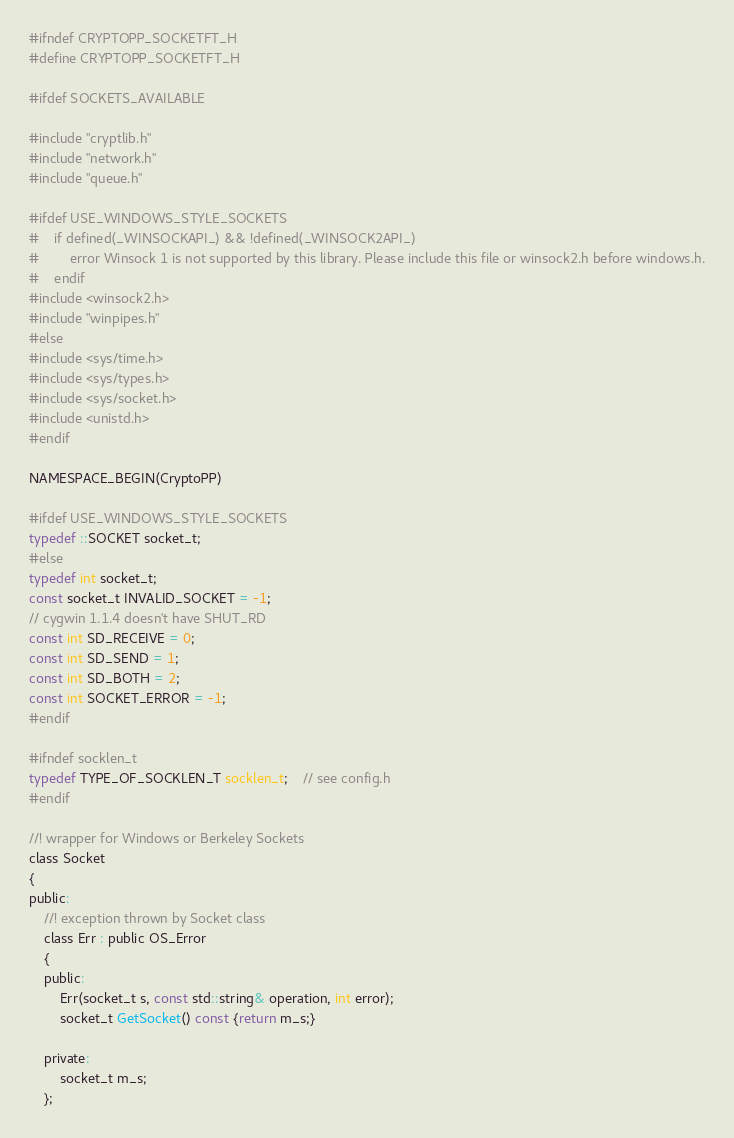Convert code to text. <code><loc_0><loc_0><loc_500><loc_500><_C_>#ifndef CRYPTOPP_SOCKETFT_H
#define CRYPTOPP_SOCKETFT_H

#ifdef SOCKETS_AVAILABLE

#include "cryptlib.h"
#include "network.h"
#include "queue.h"

#ifdef USE_WINDOWS_STYLE_SOCKETS
#	if defined(_WINSOCKAPI_) && !defined(_WINSOCK2API_)
#		error Winsock 1 is not supported by this library. Please include this file or winsock2.h before windows.h.
#	endif
#include <winsock2.h>
#include "winpipes.h"
#else
#include <sys/time.h>
#include <sys/types.h>
#include <sys/socket.h>
#include <unistd.h>
#endif

NAMESPACE_BEGIN(CryptoPP)

#ifdef USE_WINDOWS_STYLE_SOCKETS
typedef ::SOCKET socket_t;
#else
typedef int socket_t;
const socket_t INVALID_SOCKET = -1;
// cygwin 1.1.4 doesn't have SHUT_RD
const int SD_RECEIVE = 0;
const int SD_SEND = 1;
const int SD_BOTH = 2;
const int SOCKET_ERROR = -1;
#endif

#ifndef socklen_t
typedef TYPE_OF_SOCKLEN_T socklen_t;	// see config.h
#endif

//! wrapper for Windows or Berkeley Sockets
class Socket
{
public:
	//! exception thrown by Socket class
	class Err : public OS_Error
	{
	public:
		Err(socket_t s, const std::string& operation, int error);
		socket_t GetSocket() const {return m_s;}

	private:
		socket_t m_s;
	};
</code> 